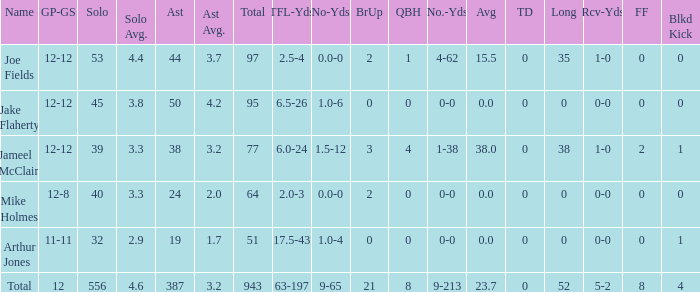How many yards for the player with tfl-yds of 2.5-4? 4-62. 